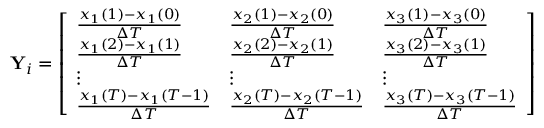<formula> <loc_0><loc_0><loc_500><loc_500>Y _ { i } = \left [ \begin{array} { l l l } { \frac { x _ { 1 } ( 1 ) - x _ { 1 } ( 0 ) } { \Delta T } } & { \frac { x _ { 2 } ( 1 ) - x _ { 2 } ( 0 ) } { \Delta T } } & { \frac { x _ { 3 } ( 1 ) - x _ { 3 } ( 0 ) } { \Delta T } } \\ { \frac { x _ { 1 } ( 2 ) - x _ { 1 } ( 1 ) } { \Delta T } } & { \frac { x _ { 2 } ( 2 ) - x _ { 2 } ( 1 ) } { \Delta T } } & { \frac { x _ { 3 } ( 2 ) - x _ { 3 } ( 1 ) } { \Delta T } } \\ { \vdots } & { \vdots } & { \vdots } \\ { \frac { x _ { 1 } ( T ) - x _ { 1 } ( T - 1 ) } { \Delta T } } & { \frac { x _ { 2 } ( T ) - x _ { 2 } ( T - 1 ) } { \Delta T } } & { \frac { x _ { 3 } ( T ) - x _ { 3 } ( T - 1 ) } { \Delta T } } \end{array} \right ]</formula> 